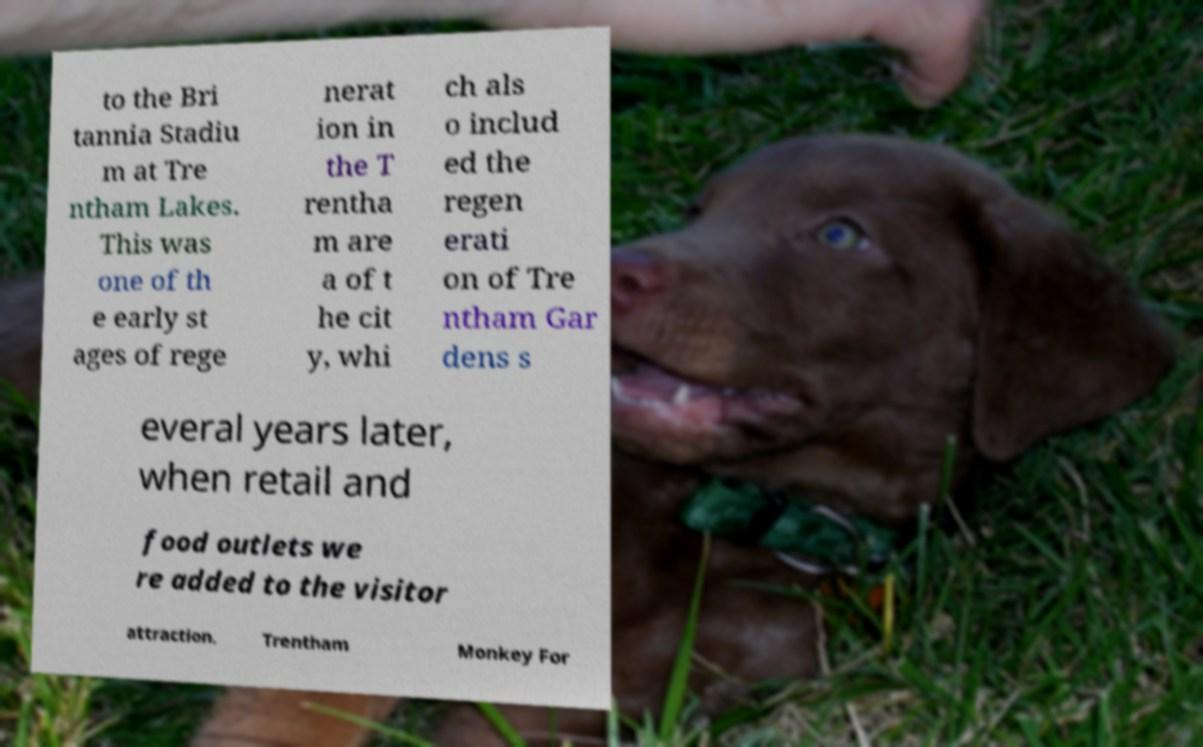I need the written content from this picture converted into text. Can you do that? to the Bri tannia Stadiu m at Tre ntham Lakes. This was one of th e early st ages of rege nerat ion in the T rentha m are a of t he cit y, whi ch als o includ ed the regen erati on of Tre ntham Gar dens s everal years later, when retail and food outlets we re added to the visitor attraction. Trentham Monkey For 